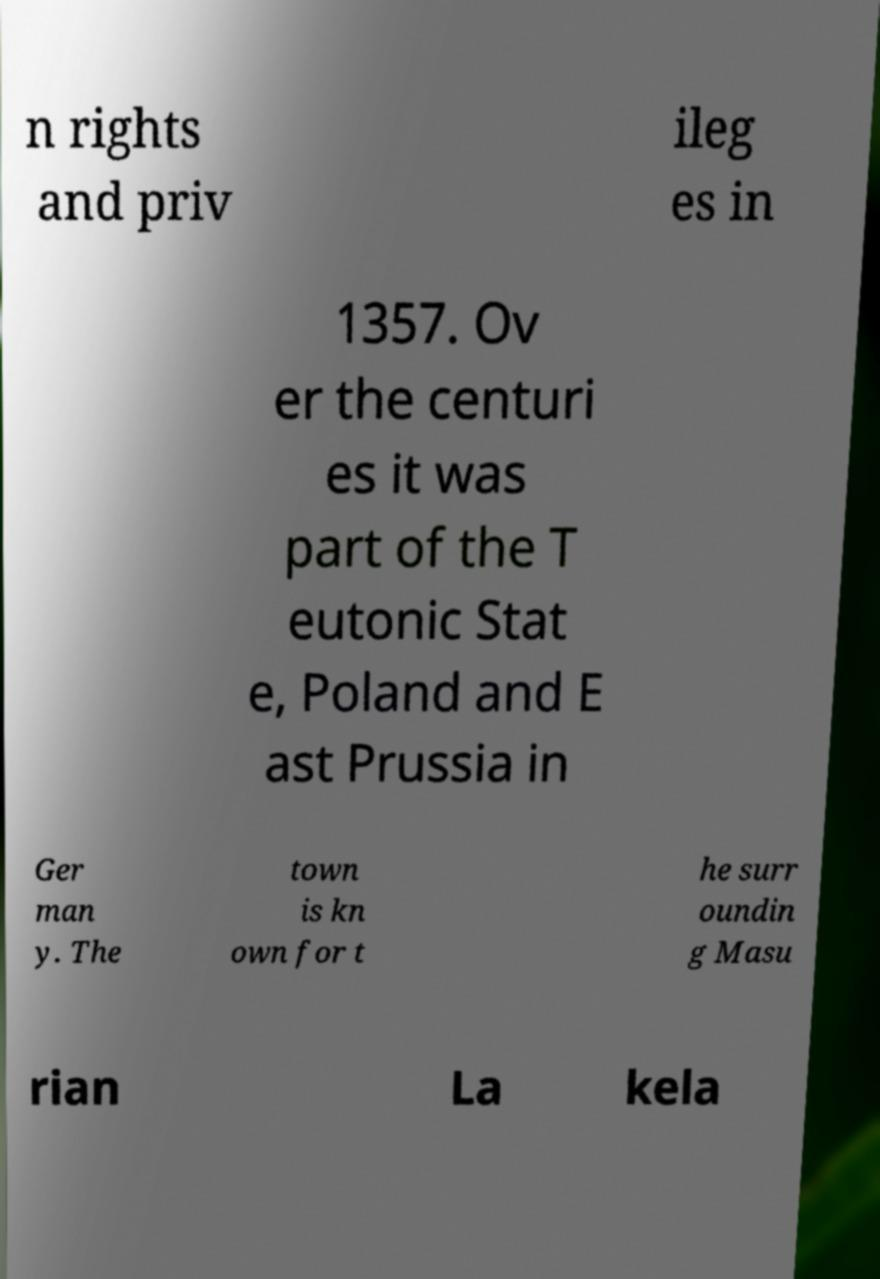What messages or text are displayed in this image? I need them in a readable, typed format. n rights and priv ileg es in 1357. Ov er the centuri es it was part of the T eutonic Stat e, Poland and E ast Prussia in Ger man y. The town is kn own for t he surr oundin g Masu rian La kela 